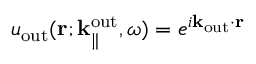Convert formula to latex. <formula><loc_0><loc_0><loc_500><loc_500>u _ { o u t } ( { r } ; { k } _ { \| } ^ { o u t } , \omega ) = e ^ { i { k } _ { o u t } \cdot { r } }</formula> 